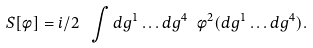<formula> <loc_0><loc_0><loc_500><loc_500>S [ \phi ] = i / 2 \ \int d g ^ { 1 } \dots d g ^ { 4 } \ \phi ^ { 2 } ( d g ^ { 1 } \dots d g ^ { 4 } ) .</formula> 